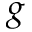<formula> <loc_0><loc_0><loc_500><loc_500>g</formula> 